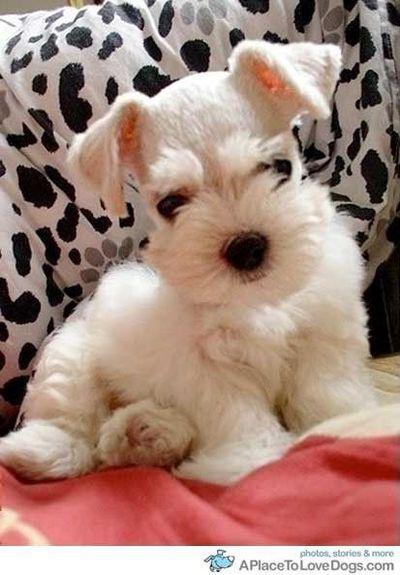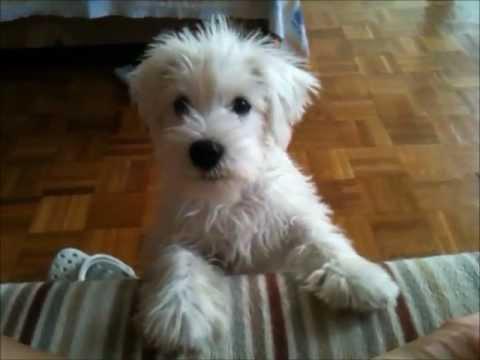The first image is the image on the left, the second image is the image on the right. For the images displayed, is the sentence "Each image contains one white dog, and the dog on the right is posed by striped fabric." factually correct? Answer yes or no. Yes. The first image is the image on the left, the second image is the image on the right. Given the left and right images, does the statement "The image on the left is either of a group of puppies huddled together or of a single white dog wearing a red collar." hold true? Answer yes or no. No. 